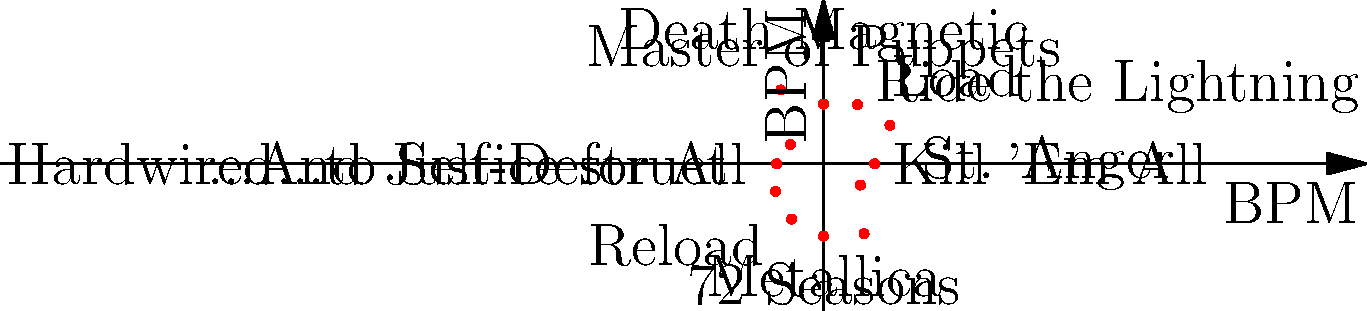The polar coordinate plot shows the distribution of song tempos (in beats per minute) across Metallica's studio albums. Which album appears to have the highest average tempo based on this visualization? To determine which album has the highest average tempo, we need to analyze the plot:

1. Each point on the plot represents an album, with the distance from the center indicating the tempo.
2. The further a point is from the center, the higher the tempo.
3. Examining the plot, we can see that:
   - "Kill 'Em All" is at (120, 0)
   - "Ride the Lightning" is at (90, 90)
   - "Master of Puppets" is at (0, 160)
   - "...And Justice for All" is at (-140, 0)
   - "Metallica" is at (0, -170)
   - "Load" is at (130, 130)
   - "Reload" is at (-110, -110)
   - "St. Anger" is at (190, 0)
   - "Death Magnetic" is at (0, 200)
   - "Hardwired...to Self-Destruct" is at (-180, 0)
   - "72 Seasons" is at (0, -190)

4. The point furthest from the center represents the album with the highest average tempo.
5. Visually, we can see that "Death Magnetic" at (0, 200) is the furthest point from the center.

Therefore, based on this visualization, "Death Magnetic" appears to have the highest average tempo among Metallica's studio albums.
Answer: Death Magnetic 